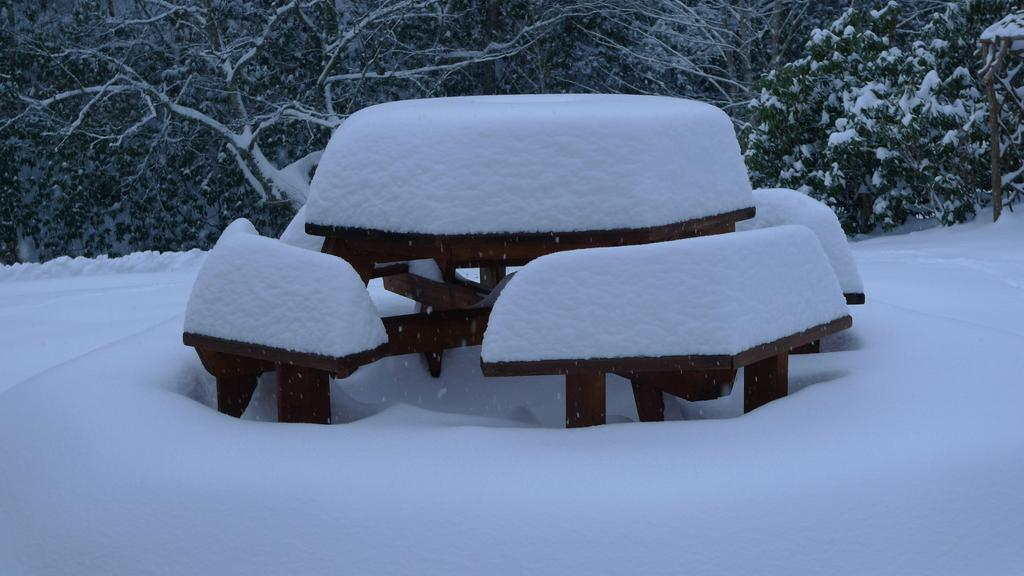What is the primary weather condition depicted in the image? There is snow in the image. What type of natural elements can be seen in the image? There are trees at the top side of the image. What type of bell can be heard ringing during the party in the image? There is no party or bell present in the image; it features snow and trees. 